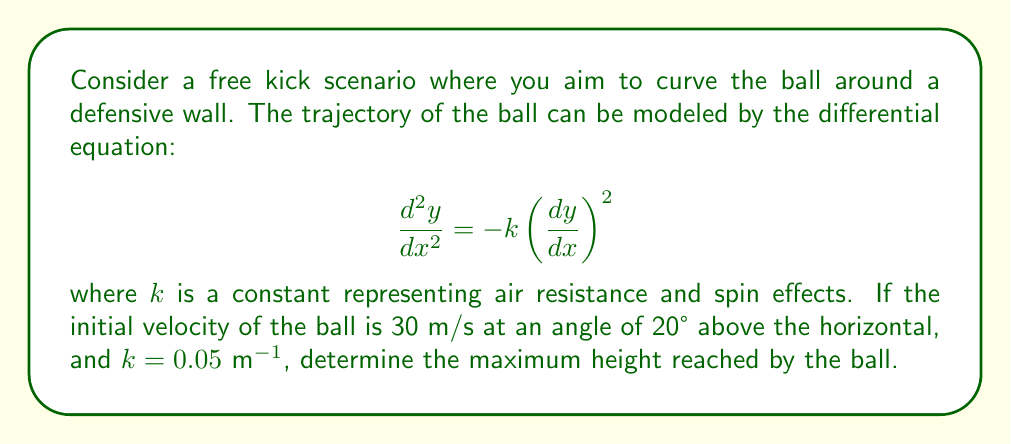Can you solve this math problem? To solve this problem, we'll follow these steps:

1) First, let's break down the initial velocity into its horizontal and vertical components:
   
   $v_x = 30 \cos(20°) \approx 28.19$ m/s
   $v_y = 30 \sin(20°) \approx 10.26$ m/s

2) The differential equation can be solved by separation of variables:

   $$\frac{d^2y}{dx^2} = -k\left(\frac{dy}{dx}\right)^2$$
   $$\frac{d(\frac{dy}{dx})}{dx} = -k\left(\frac{dy}{dx}\right)^2$$
   $$\int \frac{d(\frac{dy}{dx})}{\left(\frac{dy}{dx}\right)^2} = -k \int dx$$
   $$-\frac{1}{\frac{dy}{dx}} = -kx + C$$

3) Solving for $\frac{dy}{dx}$:

   $$\frac{dy}{dx} = \frac{1}{kx - C}$$

4) Using the initial conditions, we can find C:

   At $x=0$, $\frac{dy}{dx} = \tan(20°) \approx 0.3640$
   
   $$0.3640 = \frac{1}{-C}$$
   $$C = -2.7473$$

5) Now we have:

   $$\frac{dy}{dx} = \frac{1}{0.05x + 2.7473}$$

6) To find the maximum height, we need to find where $\frac{dy}{dx} = 0$:

   $$0 = \frac{1}{0.05x + 2.7473}$$
   $$0.05x + 2.7473 = \infty$$
   $$x \to \infty$$

   This means the ball will continue to rise (theoretically) as x increases.

7) However, in practical terms, we can calculate the height at a reasonable distance. Let's use the range of a typical free kick, about 25 meters:

   $$y = \int_0^{25} \frac{1}{0.05x + 2.7473} dx$$
   $$y = \frac{1}{0.05} \ln(0.05x + 2.7473) \bigg|_0^{25}$$
   $$y = 20(\ln(4.0223) - \ln(2.7473)) \approx 7.67$$ meters

Therefore, at a distance of 25 meters, the ball would reach a height of approximately 7.67 meters.
Answer: 7.67 meters 